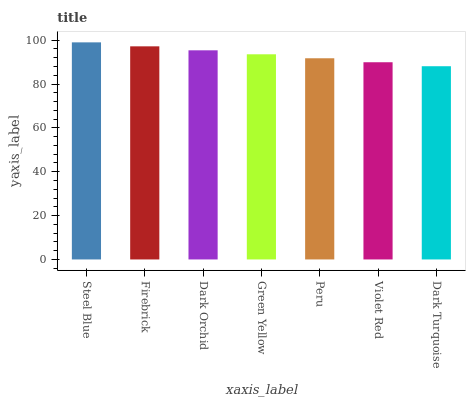Is Firebrick the minimum?
Answer yes or no. No. Is Firebrick the maximum?
Answer yes or no. No. Is Steel Blue greater than Firebrick?
Answer yes or no. Yes. Is Firebrick less than Steel Blue?
Answer yes or no. Yes. Is Firebrick greater than Steel Blue?
Answer yes or no. No. Is Steel Blue less than Firebrick?
Answer yes or no. No. Is Green Yellow the high median?
Answer yes or no. Yes. Is Green Yellow the low median?
Answer yes or no. Yes. Is Violet Red the high median?
Answer yes or no. No. Is Violet Red the low median?
Answer yes or no. No. 